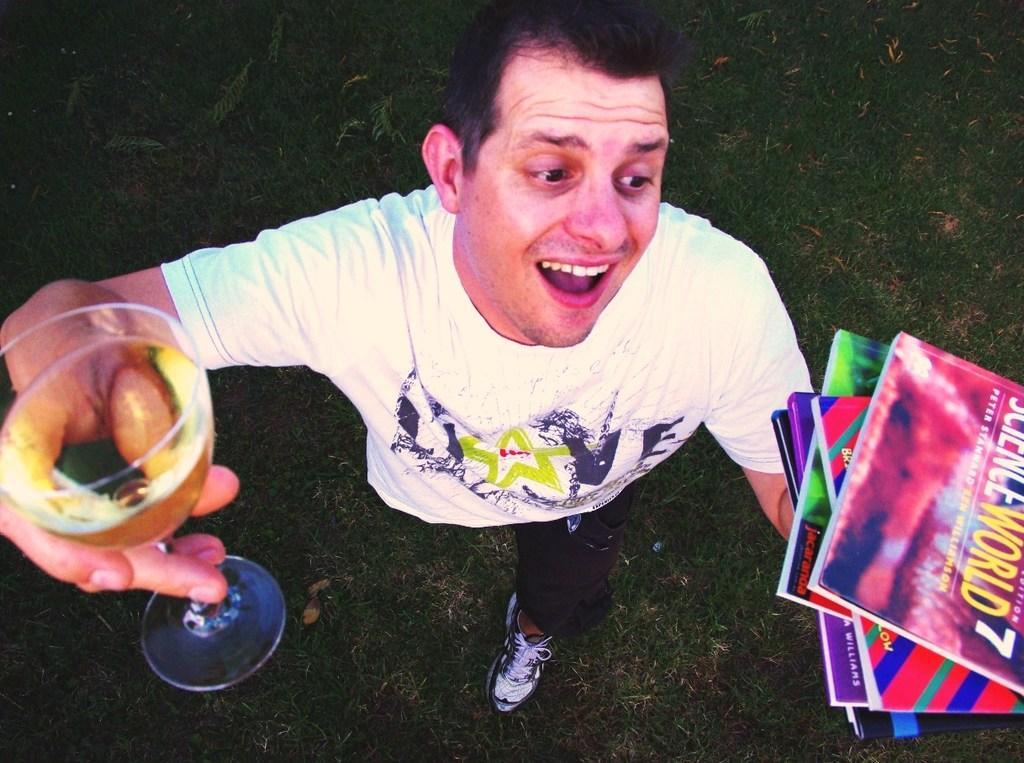Please provide a concise description of this image. In this image we can see a man is standing on the grass and holding a glass with liquid in it in the hand and books in the another hand. 